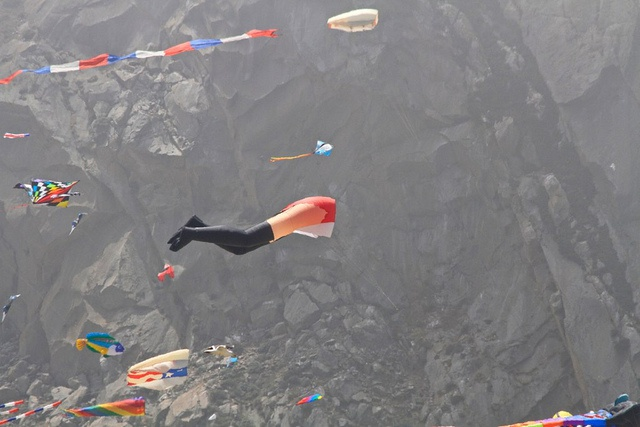Describe the objects in this image and their specific colors. I can see kite in darkgray, black, gray, and salmon tones, kite in darkgray, gray, and lavender tones, kite in darkgray, lightgray, and lightpink tones, kite in darkgray, tan, and beige tones, and kite in darkgray, gray, lightgray, and brown tones in this image. 